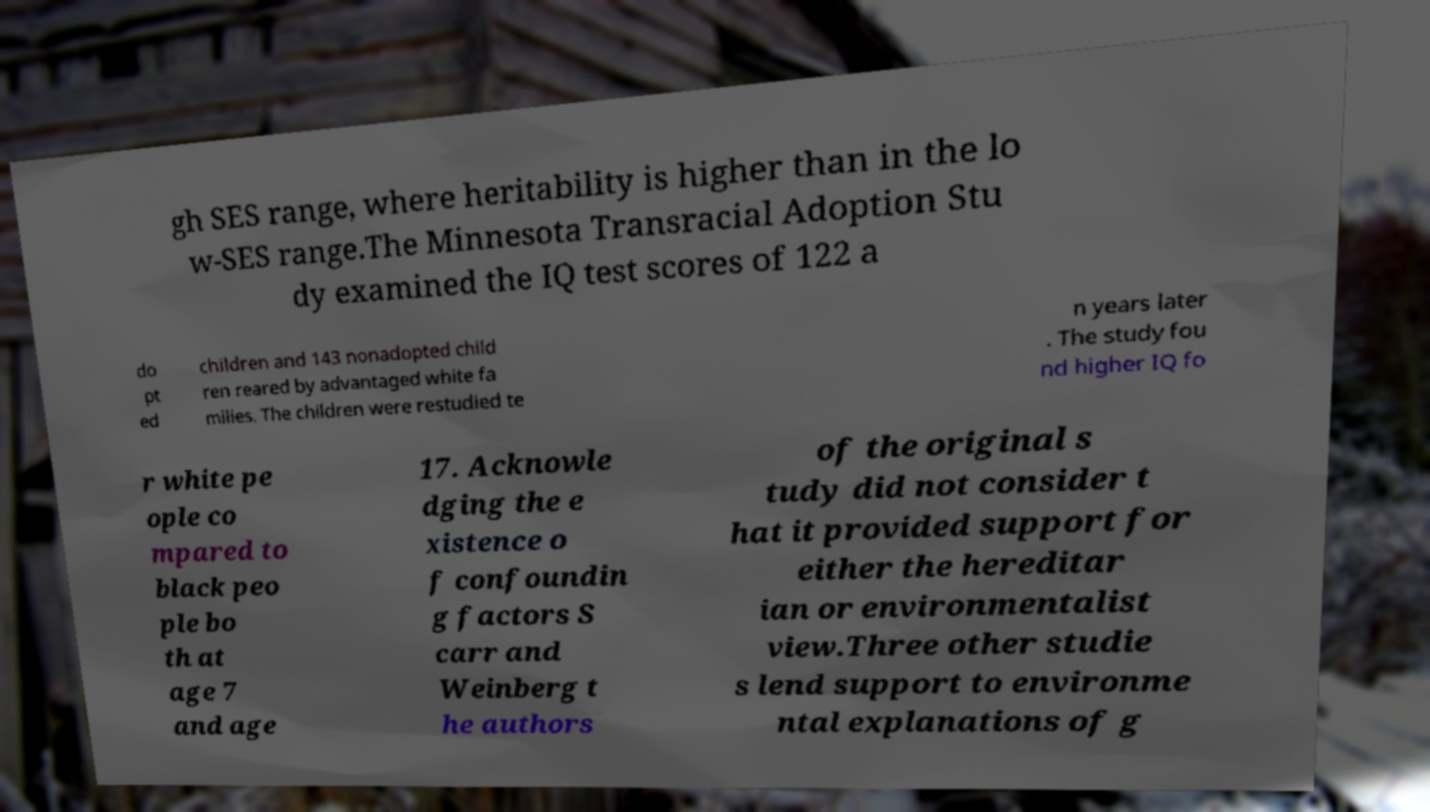Can you accurately transcribe the text from the provided image for me? gh SES range, where heritability is higher than in the lo w-SES range.The Minnesota Transracial Adoption Stu dy examined the IQ test scores of 122 a do pt ed children and 143 nonadopted child ren reared by advantaged white fa milies. The children were restudied te n years later . The study fou nd higher IQ fo r white pe ople co mpared to black peo ple bo th at age 7 and age 17. Acknowle dging the e xistence o f confoundin g factors S carr and Weinberg t he authors of the original s tudy did not consider t hat it provided support for either the hereditar ian or environmentalist view.Three other studie s lend support to environme ntal explanations of g 